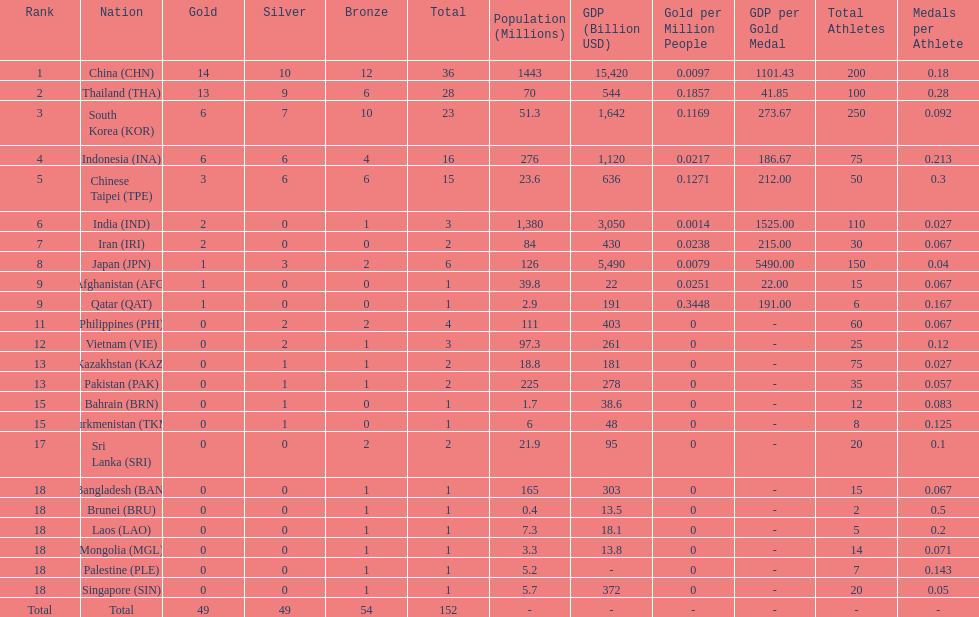How many combined silver medals did china, india, and japan earn ? 13. 